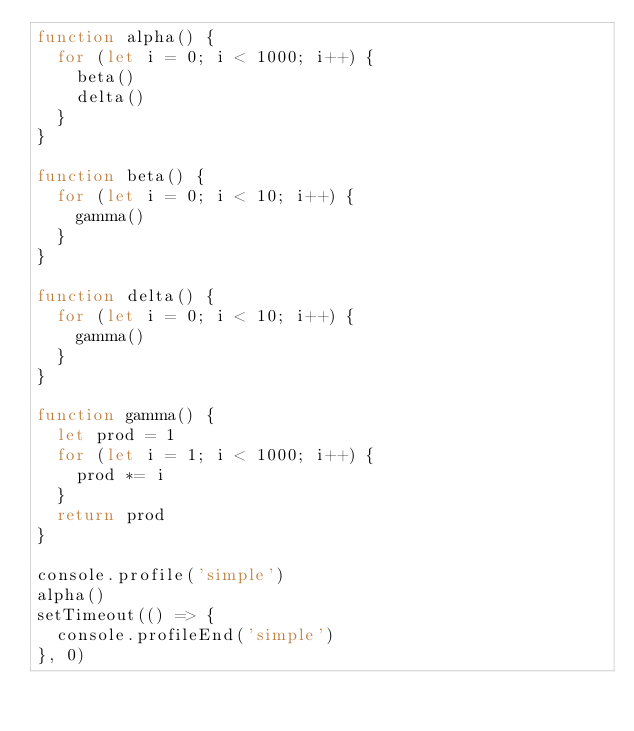Convert code to text. <code><loc_0><loc_0><loc_500><loc_500><_JavaScript_>function alpha() {
  for (let i = 0; i < 1000; i++) {
    beta()
    delta()
  }
}

function beta() {
  for (let i = 0; i < 10; i++) {
    gamma()
  }
}

function delta() {
  for (let i = 0; i < 10; i++) {
    gamma()
  }
}

function gamma() {
  let prod = 1
  for (let i = 1; i < 1000; i++) {
    prod *= i
  }
  return prod
}

console.profile('simple')
alpha()
setTimeout(() => {
  console.profileEnd('simple')
}, 0)
</code> 